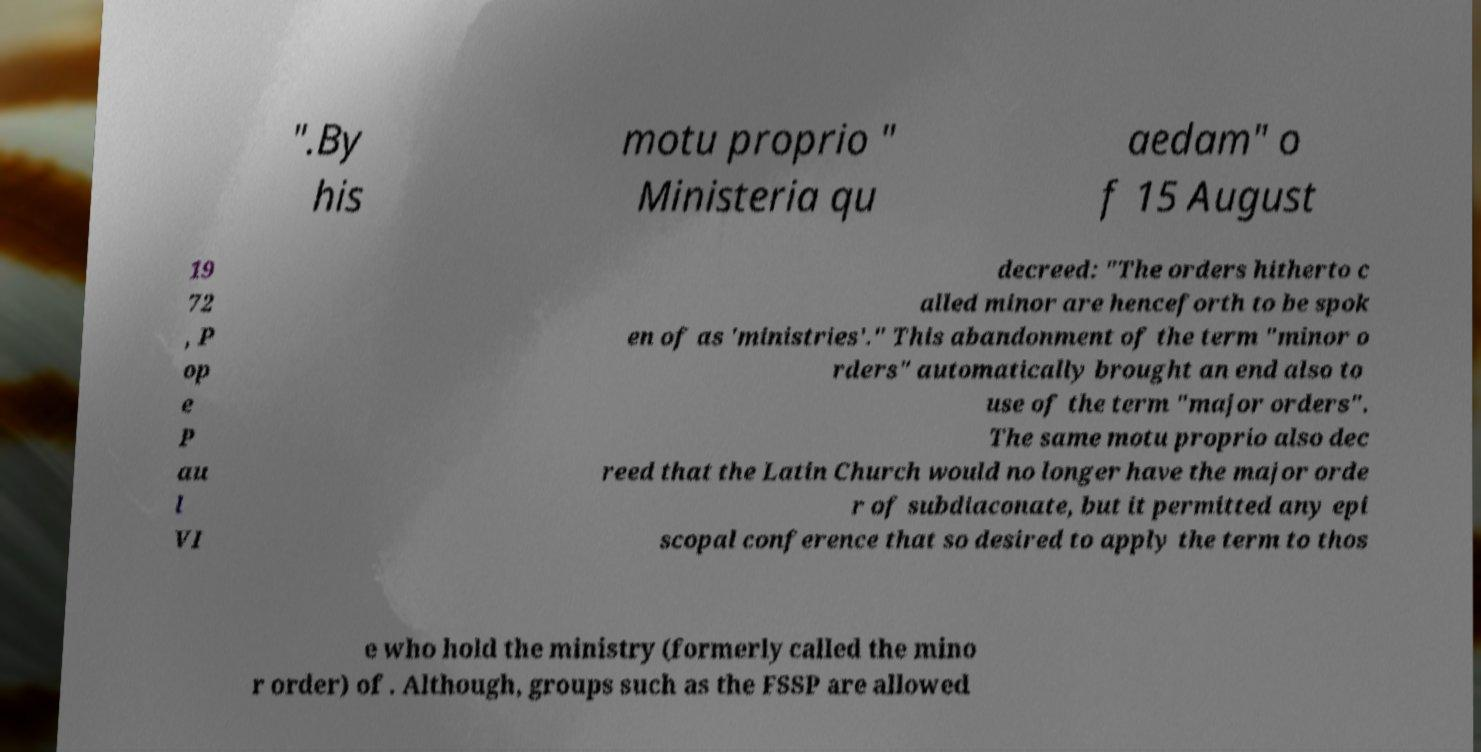Could you extract and type out the text from this image? ".By his motu proprio " Ministeria qu aedam" o f 15 August 19 72 , P op e P au l VI decreed: "The orders hitherto c alled minor are henceforth to be spok en of as 'ministries'." This abandonment of the term "minor o rders" automatically brought an end also to use of the term "major orders". The same motu proprio also dec reed that the Latin Church would no longer have the major orde r of subdiaconate, but it permitted any epi scopal conference that so desired to apply the term to thos e who hold the ministry (formerly called the mino r order) of . Although, groups such as the FSSP are allowed 